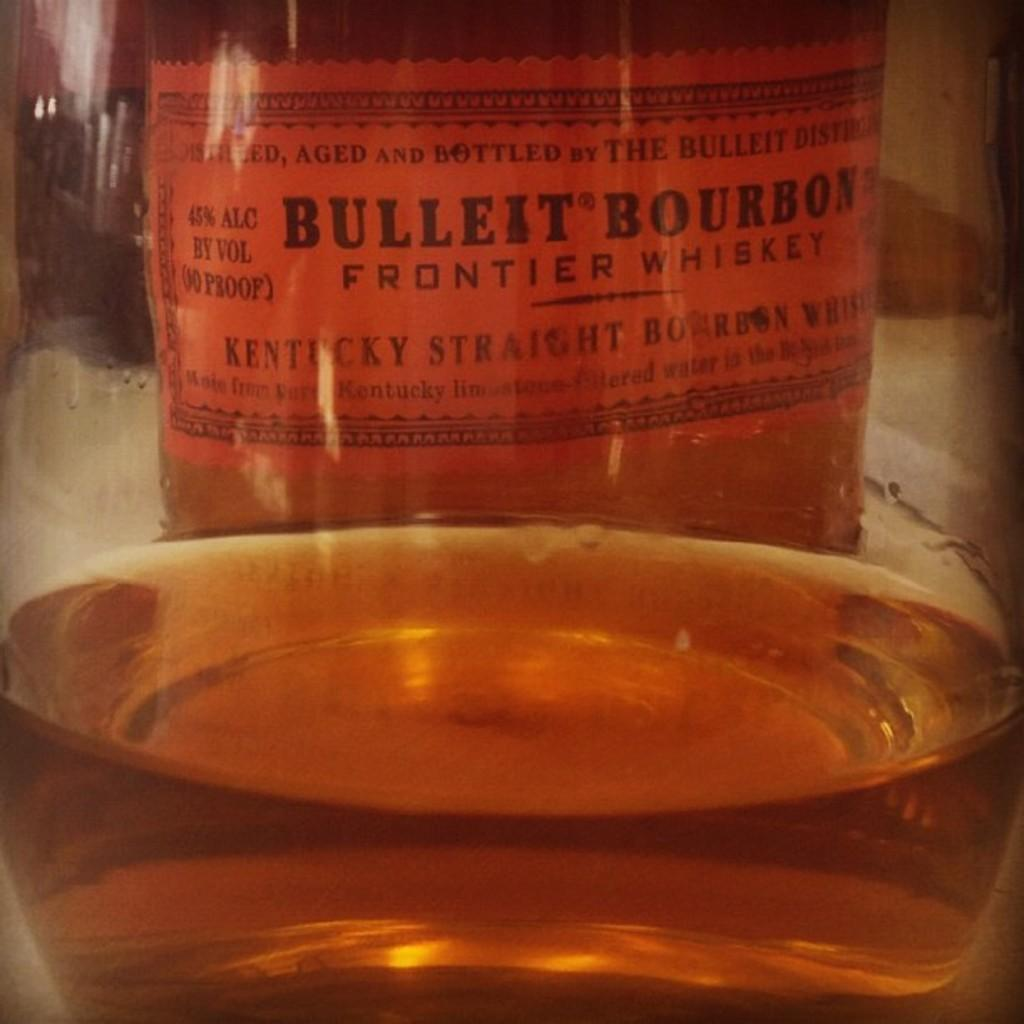What object is present in the image that contains a drink? There is a bottle in the image that contains a drink. What can be found on the bottle? There is a label on the bottle. What information is provided on the label? The label has something written on it. How many gooses are visible in the image? There are no gooses present in the image. What type of worm can be seen crawling on the label of the bottle? There is no worm present on the label of the bottle; it only has something written on it. 